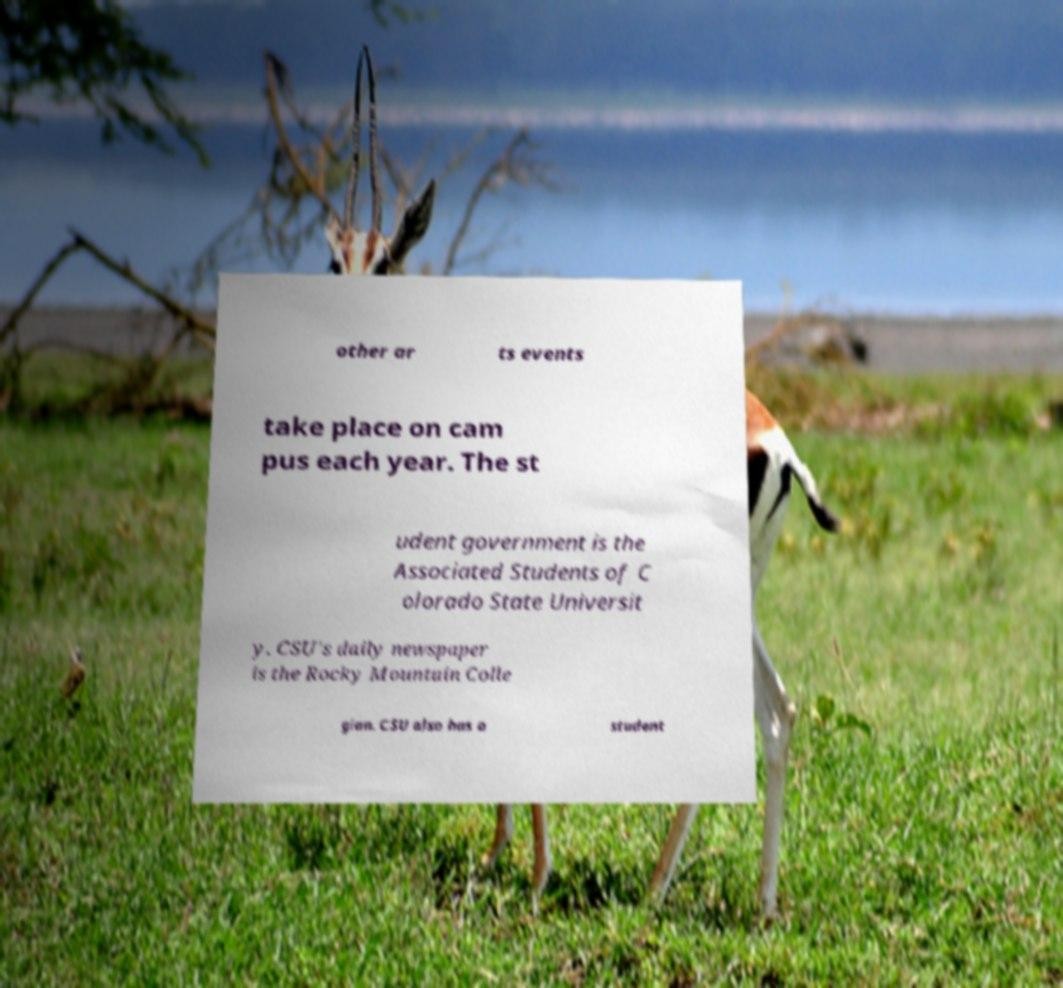Please read and relay the text visible in this image. What does it say? other ar ts events take place on cam pus each year. The st udent government is the Associated Students of C olorado State Universit y. CSU's daily newspaper is the Rocky Mountain Colle gian. CSU also has a student 